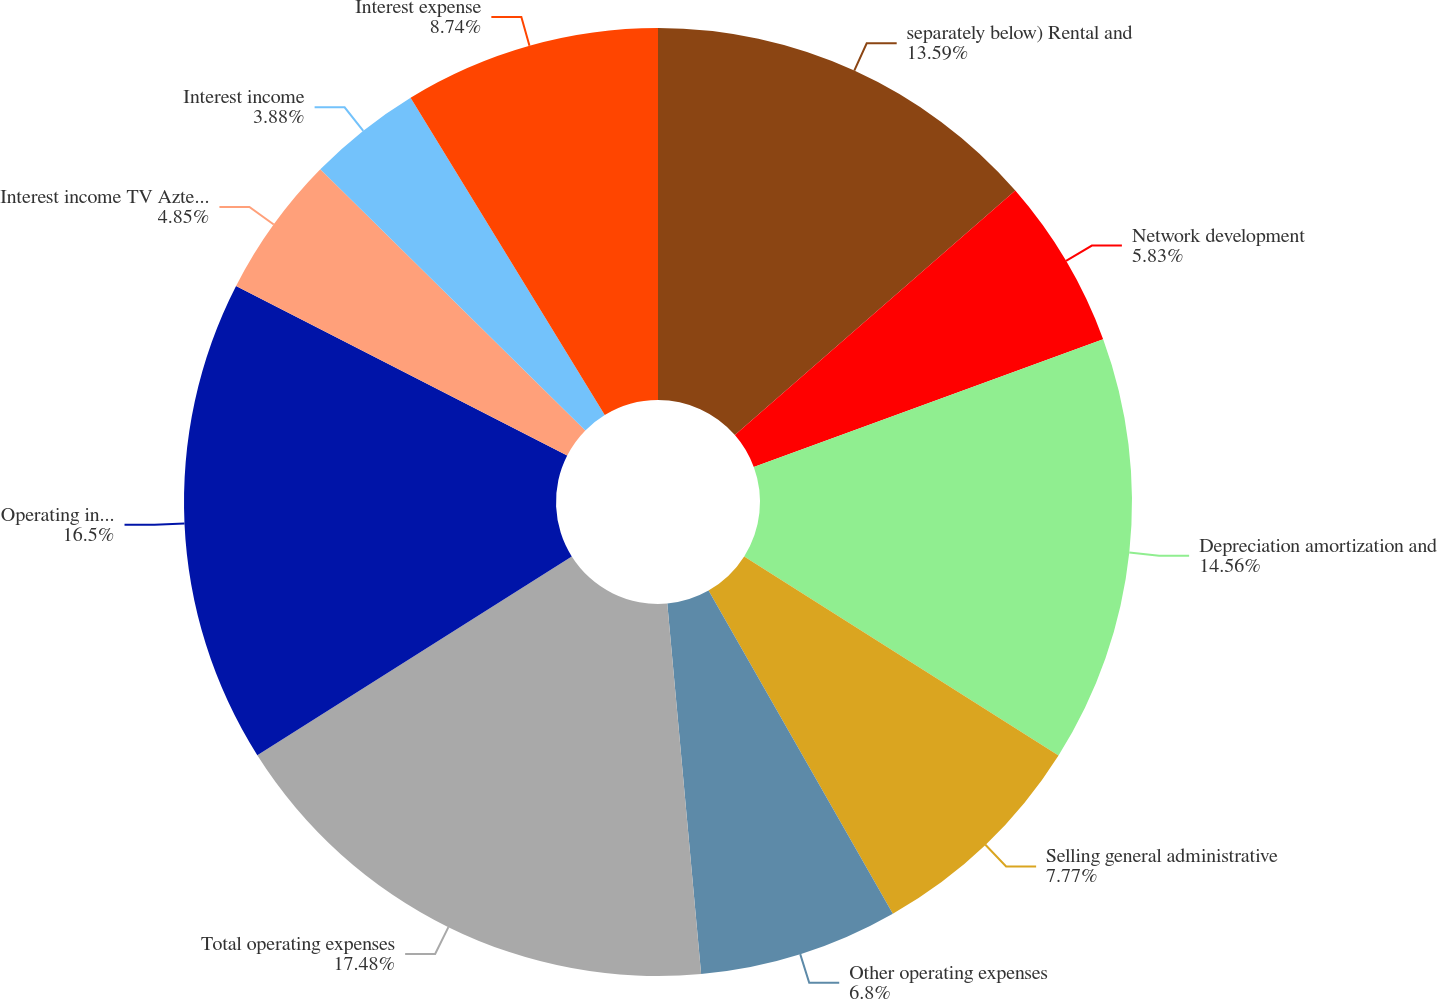Convert chart to OTSL. <chart><loc_0><loc_0><loc_500><loc_500><pie_chart><fcel>separately below) Rental and<fcel>Network development<fcel>Depreciation amortization and<fcel>Selling general administrative<fcel>Other operating expenses<fcel>Total operating expenses<fcel>Operating income<fcel>Interest income TV Azteca net<fcel>Interest income<fcel>Interest expense<nl><fcel>13.59%<fcel>5.83%<fcel>14.56%<fcel>7.77%<fcel>6.8%<fcel>17.48%<fcel>16.5%<fcel>4.85%<fcel>3.88%<fcel>8.74%<nl></chart> 